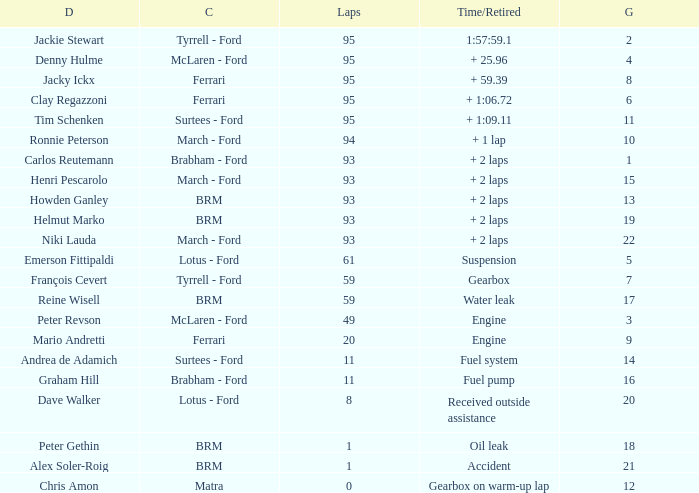What is the total number of grids for peter gethin? 18.0. 